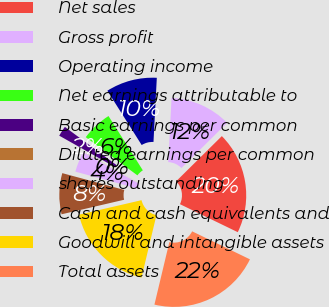Convert chart. <chart><loc_0><loc_0><loc_500><loc_500><pie_chart><fcel>Net sales<fcel>Gross profit<fcel>Operating income<fcel>Net earnings attributable to<fcel>Basic earnings per common<fcel>Diluted earnings per common<fcel>shares outstanding<fcel>Cash and cash equivalents and<fcel>Goodwill and intangible assets<fcel>Total assets<nl><fcel>19.59%<fcel>11.76%<fcel>9.8%<fcel>5.89%<fcel>1.97%<fcel>0.02%<fcel>3.93%<fcel>7.85%<fcel>17.63%<fcel>21.55%<nl></chart> 